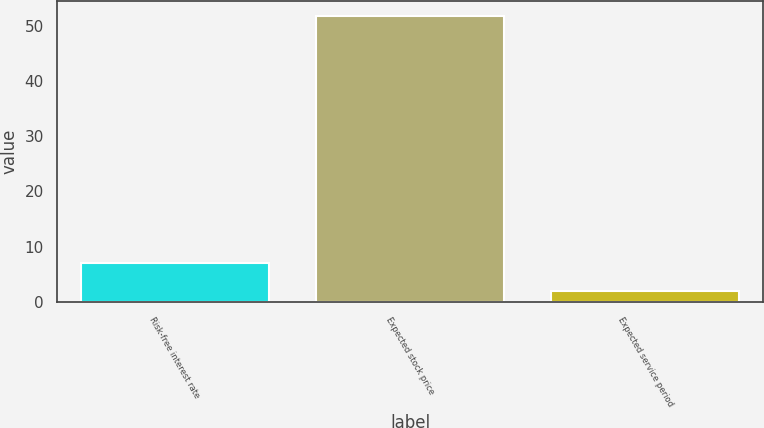Convert chart. <chart><loc_0><loc_0><loc_500><loc_500><bar_chart><fcel>Risk-free interest rate<fcel>Expected stock price<fcel>Expected service period<nl><fcel>6.98<fcel>51.8<fcel>2<nl></chart> 